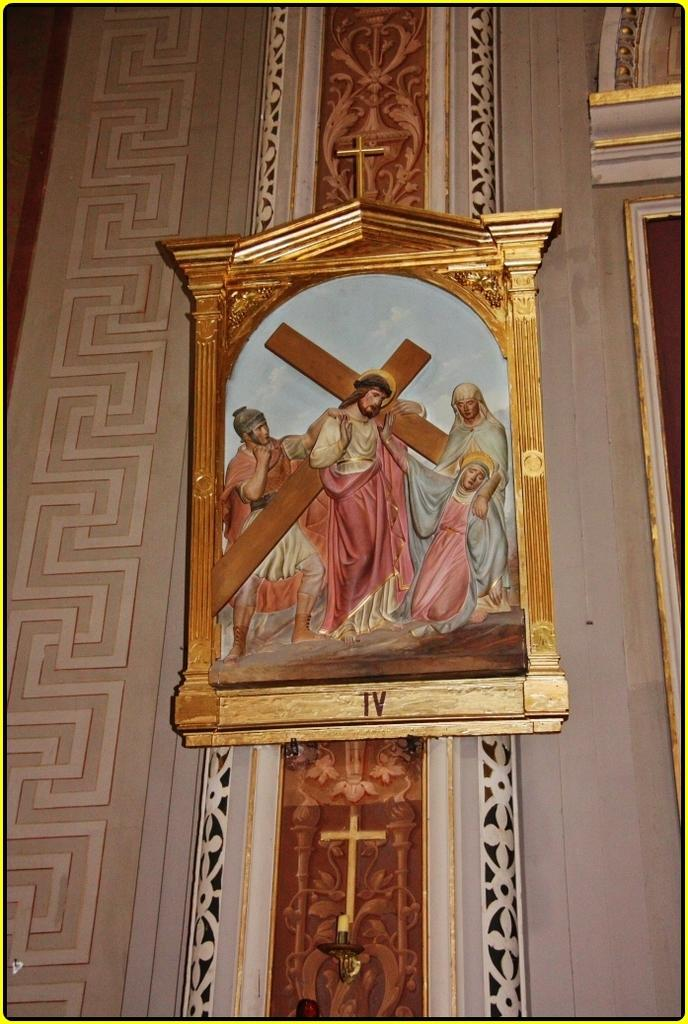Provide a one-sentence caption for the provided image. A picture of Jesus Christ carrying a cross in a frame with "IV" written on the bottom. 